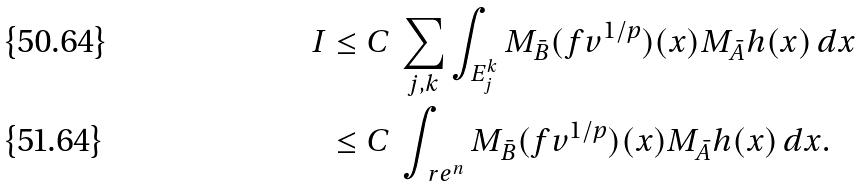Convert formula to latex. <formula><loc_0><loc_0><loc_500><loc_500>I & \leq C \, \sum _ { j , k } \int _ { E _ { j } ^ { k } } M _ { \bar { B } } ( f v ^ { 1 / p } ) ( x ) M _ { \bar { A } } h ( x ) \, d x \\ & \leq C \, \int _ { \ r e ^ { n } } M _ { \bar { B } } ( f v ^ { 1 / p } ) ( x ) M _ { \bar { A } } h ( x ) \, d x .</formula> 